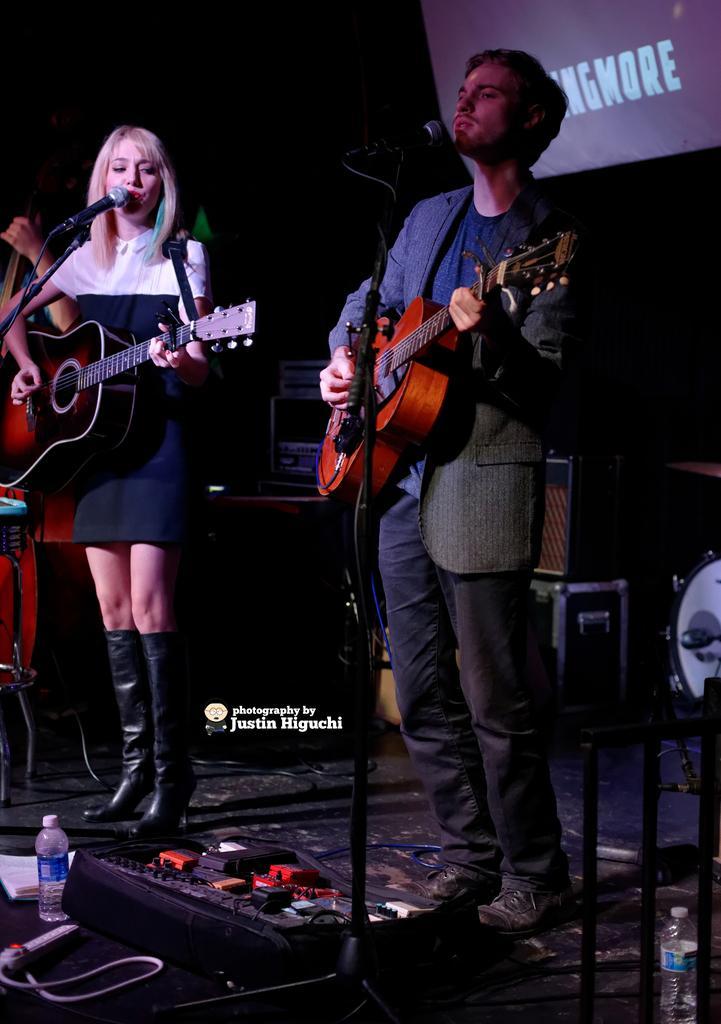Can you describe this image briefly? In this picture we can see man and woman holding guitars in their hands and playing it and singing on mics they are standing on stage with bottle, books, speakers, drums on it. 